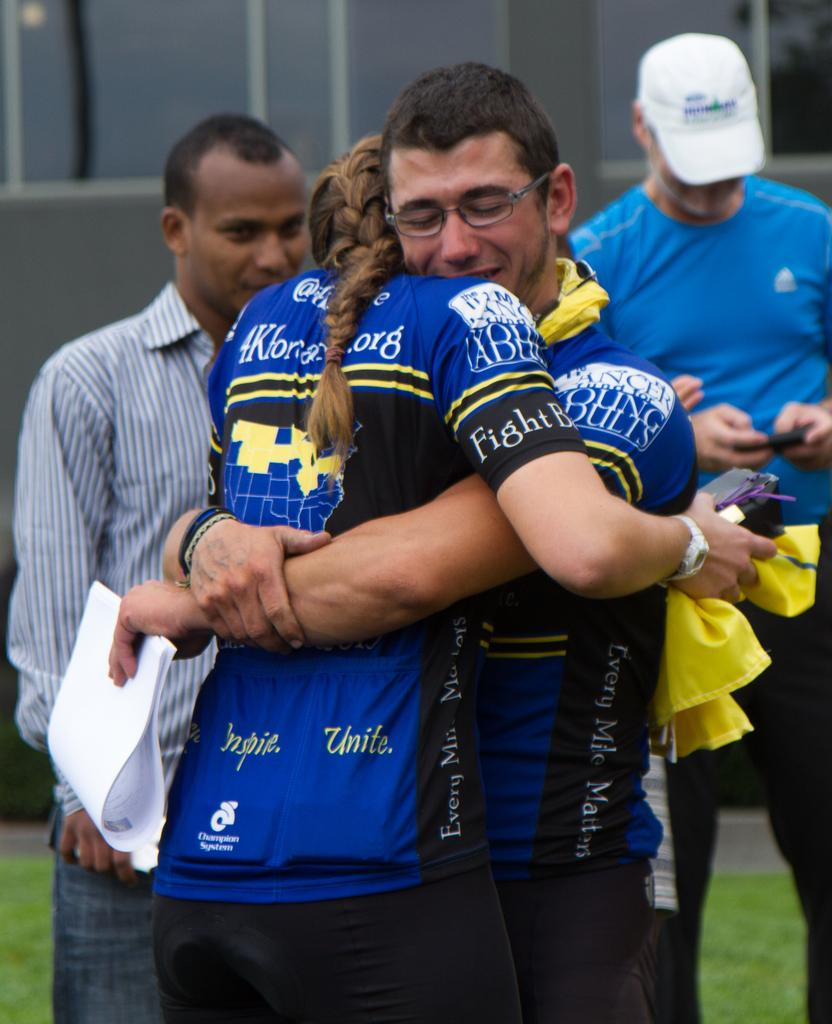<image>
Offer a succinct explanation of the picture presented. Male and female teammates hugging in blue jerseys that say "Champion System" 